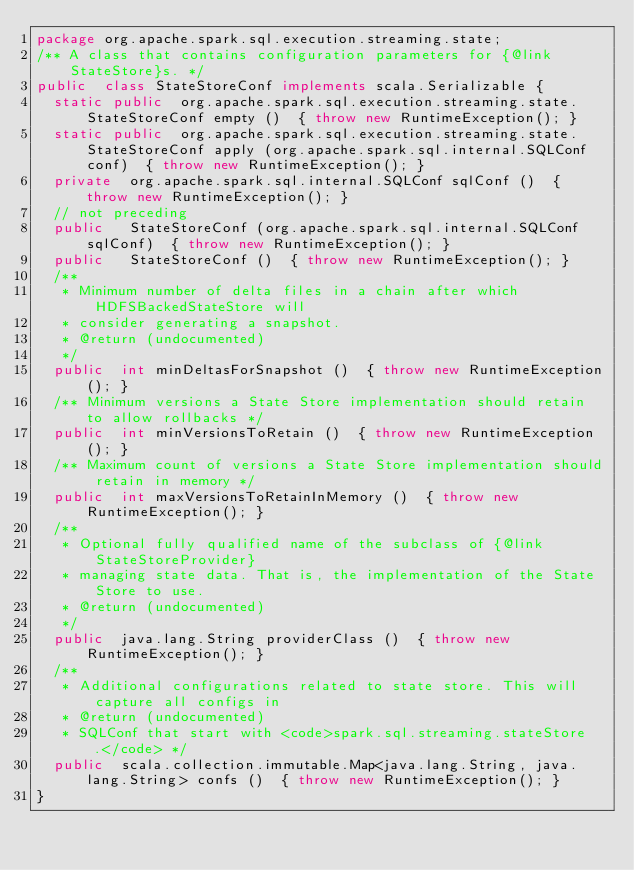Convert code to text. <code><loc_0><loc_0><loc_500><loc_500><_Java_>package org.apache.spark.sql.execution.streaming.state;
/** A class that contains configuration parameters for {@link StateStore}s. */
public  class StateStoreConf implements scala.Serializable {
  static public  org.apache.spark.sql.execution.streaming.state.StateStoreConf empty ()  { throw new RuntimeException(); }
  static public  org.apache.spark.sql.execution.streaming.state.StateStoreConf apply (org.apache.spark.sql.internal.SQLConf conf)  { throw new RuntimeException(); }
  private  org.apache.spark.sql.internal.SQLConf sqlConf ()  { throw new RuntimeException(); }
  // not preceding
  public   StateStoreConf (org.apache.spark.sql.internal.SQLConf sqlConf)  { throw new RuntimeException(); }
  public   StateStoreConf ()  { throw new RuntimeException(); }
  /**
   * Minimum number of delta files in a chain after which HDFSBackedStateStore will
   * consider generating a snapshot.
   * @return (undocumented)
   */
  public  int minDeltasForSnapshot ()  { throw new RuntimeException(); }
  /** Minimum versions a State Store implementation should retain to allow rollbacks */
  public  int minVersionsToRetain ()  { throw new RuntimeException(); }
  /** Maximum count of versions a State Store implementation should retain in memory */
  public  int maxVersionsToRetainInMemory ()  { throw new RuntimeException(); }
  /**
   * Optional fully qualified name of the subclass of {@link StateStoreProvider}
   * managing state data. That is, the implementation of the State Store to use.
   * @return (undocumented)
   */
  public  java.lang.String providerClass ()  { throw new RuntimeException(); }
  /**
   * Additional configurations related to state store. This will capture all configs in
   * @return (undocumented)
   * SQLConf that start with <code>spark.sql.streaming.stateStore.</code> */
  public  scala.collection.immutable.Map<java.lang.String, java.lang.String> confs ()  { throw new RuntimeException(); }
}
</code> 